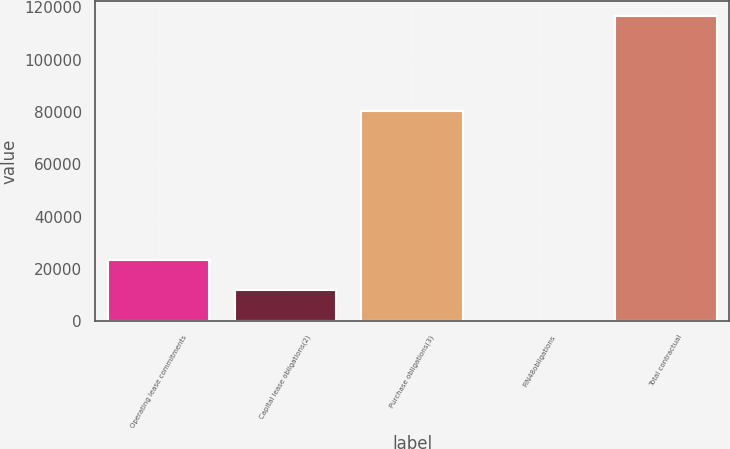Convert chart to OTSL. <chart><loc_0><loc_0><loc_500><loc_500><bar_chart><fcel>Operating lease commitments<fcel>Capital lease obligations(2)<fcel>Purchase obligations(3)<fcel>FIN48obligations<fcel>Total contractual<nl><fcel>23525.4<fcel>11879.7<fcel>80340<fcel>234<fcel>116691<nl></chart> 